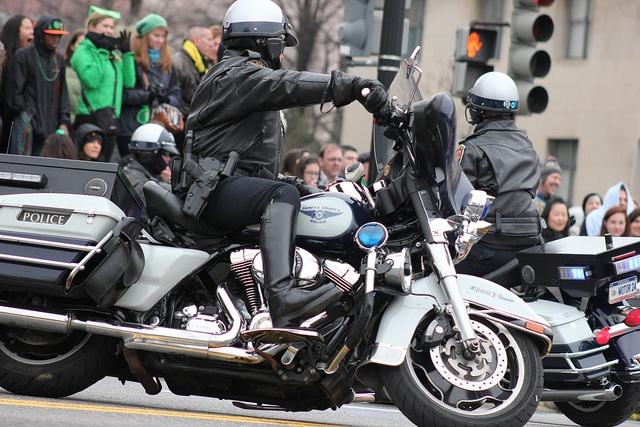Describe the objects in this image and their specific colors. I can see motorcycle in gray, black, white, and darkgray tones, people in gray, black, darkgray, and white tones, motorcycle in gray, black, lightgray, and darkgray tones, people in gray, black, darkgray, and white tones, and people in gray, black, and darkgray tones in this image. 